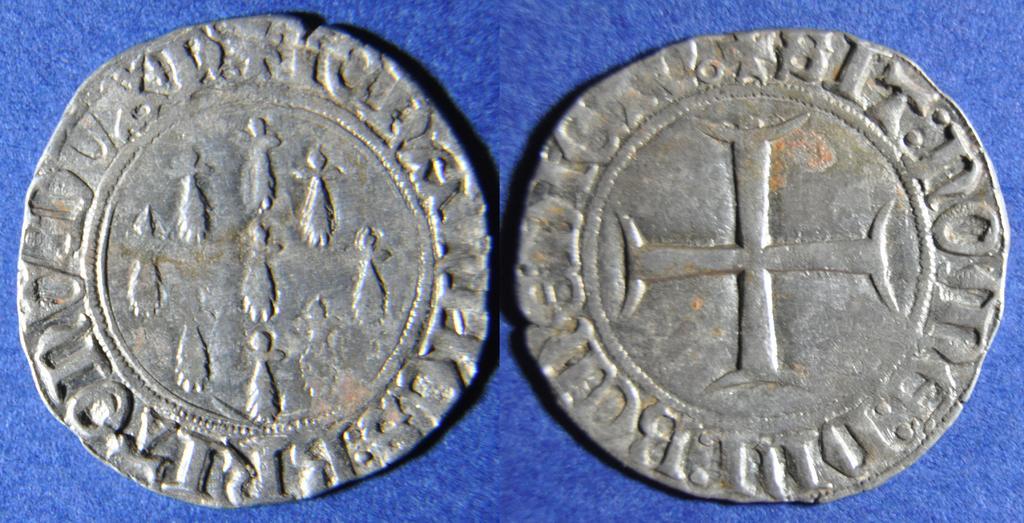Describe this image in one or two sentences. In this image I see 2 coins on the blue color surface. 